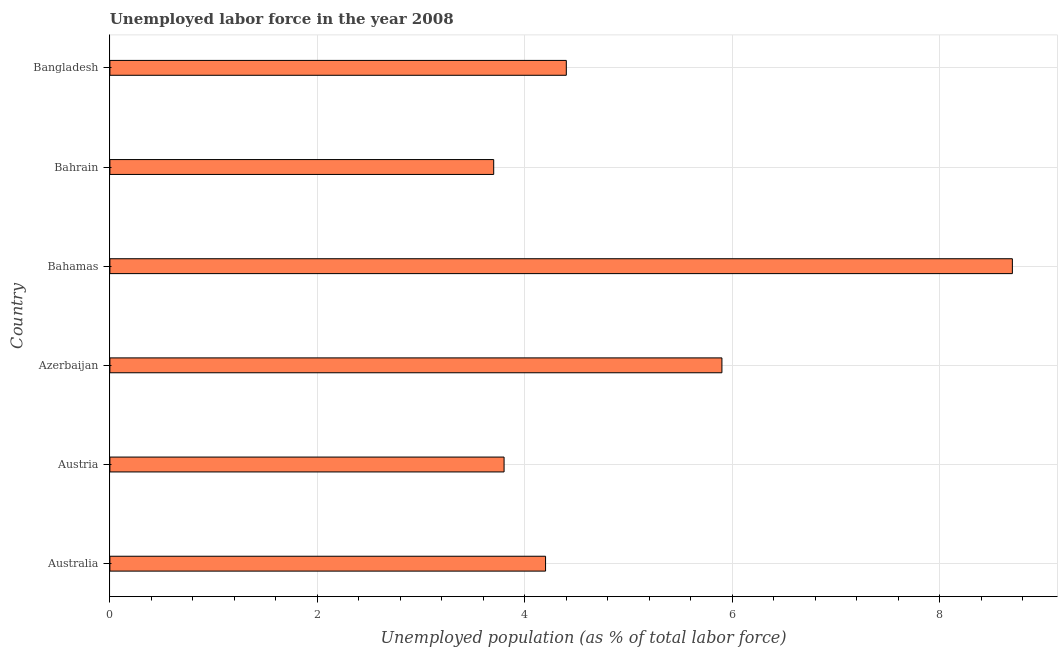Does the graph contain grids?
Your answer should be compact. Yes. What is the title of the graph?
Provide a succinct answer. Unemployed labor force in the year 2008. What is the label or title of the X-axis?
Your answer should be compact. Unemployed population (as % of total labor force). What is the total unemployed population in Azerbaijan?
Make the answer very short. 5.9. Across all countries, what is the maximum total unemployed population?
Your answer should be very brief. 8.7. Across all countries, what is the minimum total unemployed population?
Provide a succinct answer. 3.7. In which country was the total unemployed population maximum?
Your response must be concise. Bahamas. In which country was the total unemployed population minimum?
Keep it short and to the point. Bahrain. What is the sum of the total unemployed population?
Keep it short and to the point. 30.7. What is the difference between the total unemployed population in Australia and Azerbaijan?
Provide a short and direct response. -1.7. What is the average total unemployed population per country?
Provide a short and direct response. 5.12. What is the median total unemployed population?
Make the answer very short. 4.3. What is the ratio of the total unemployed population in Bahamas to that in Bahrain?
Make the answer very short. 2.35. What is the difference between the highest and the second highest total unemployed population?
Provide a succinct answer. 2.8. Is the sum of the total unemployed population in Bahrain and Bangladesh greater than the maximum total unemployed population across all countries?
Keep it short and to the point. No. What is the difference between the highest and the lowest total unemployed population?
Your response must be concise. 5. In how many countries, is the total unemployed population greater than the average total unemployed population taken over all countries?
Provide a succinct answer. 2. How many bars are there?
Make the answer very short. 6. How many countries are there in the graph?
Ensure brevity in your answer.  6. What is the difference between two consecutive major ticks on the X-axis?
Offer a terse response. 2. Are the values on the major ticks of X-axis written in scientific E-notation?
Offer a very short reply. No. What is the Unemployed population (as % of total labor force) of Australia?
Make the answer very short. 4.2. What is the Unemployed population (as % of total labor force) of Austria?
Your response must be concise. 3.8. What is the Unemployed population (as % of total labor force) of Azerbaijan?
Provide a short and direct response. 5.9. What is the Unemployed population (as % of total labor force) in Bahamas?
Give a very brief answer. 8.7. What is the Unemployed population (as % of total labor force) of Bahrain?
Keep it short and to the point. 3.7. What is the Unemployed population (as % of total labor force) in Bangladesh?
Ensure brevity in your answer.  4.4. What is the difference between the Unemployed population (as % of total labor force) in Australia and Bahamas?
Provide a succinct answer. -4.5. What is the difference between the Unemployed population (as % of total labor force) in Australia and Bahrain?
Give a very brief answer. 0.5. What is the difference between the Unemployed population (as % of total labor force) in Australia and Bangladesh?
Make the answer very short. -0.2. What is the difference between the Unemployed population (as % of total labor force) in Austria and Bahrain?
Provide a short and direct response. 0.1. What is the difference between the Unemployed population (as % of total labor force) in Austria and Bangladesh?
Provide a short and direct response. -0.6. What is the difference between the Unemployed population (as % of total labor force) in Azerbaijan and Bahrain?
Ensure brevity in your answer.  2.2. What is the difference between the Unemployed population (as % of total labor force) in Bahamas and Bahrain?
Make the answer very short. 5. What is the difference between the Unemployed population (as % of total labor force) in Bahrain and Bangladesh?
Your response must be concise. -0.7. What is the ratio of the Unemployed population (as % of total labor force) in Australia to that in Austria?
Keep it short and to the point. 1.1. What is the ratio of the Unemployed population (as % of total labor force) in Australia to that in Azerbaijan?
Offer a very short reply. 0.71. What is the ratio of the Unemployed population (as % of total labor force) in Australia to that in Bahamas?
Provide a short and direct response. 0.48. What is the ratio of the Unemployed population (as % of total labor force) in Australia to that in Bahrain?
Offer a very short reply. 1.14. What is the ratio of the Unemployed population (as % of total labor force) in Australia to that in Bangladesh?
Your answer should be very brief. 0.95. What is the ratio of the Unemployed population (as % of total labor force) in Austria to that in Azerbaijan?
Offer a terse response. 0.64. What is the ratio of the Unemployed population (as % of total labor force) in Austria to that in Bahamas?
Offer a terse response. 0.44. What is the ratio of the Unemployed population (as % of total labor force) in Austria to that in Bahrain?
Keep it short and to the point. 1.03. What is the ratio of the Unemployed population (as % of total labor force) in Austria to that in Bangladesh?
Make the answer very short. 0.86. What is the ratio of the Unemployed population (as % of total labor force) in Azerbaijan to that in Bahamas?
Keep it short and to the point. 0.68. What is the ratio of the Unemployed population (as % of total labor force) in Azerbaijan to that in Bahrain?
Your response must be concise. 1.59. What is the ratio of the Unemployed population (as % of total labor force) in Azerbaijan to that in Bangladesh?
Make the answer very short. 1.34. What is the ratio of the Unemployed population (as % of total labor force) in Bahamas to that in Bahrain?
Provide a succinct answer. 2.35. What is the ratio of the Unemployed population (as % of total labor force) in Bahamas to that in Bangladesh?
Provide a short and direct response. 1.98. What is the ratio of the Unemployed population (as % of total labor force) in Bahrain to that in Bangladesh?
Offer a very short reply. 0.84. 